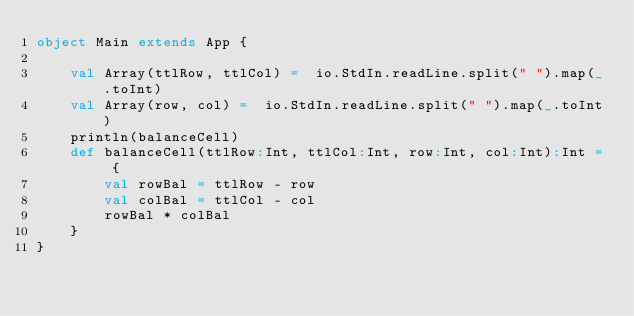<code> <loc_0><loc_0><loc_500><loc_500><_Scala_>object Main extends App {
     
    val Array(ttlRow, ttlCol) =  io.StdIn.readLine.split(" ").map(_.toInt)
    val Array(row, col) =  io.StdIn.readLine.split(" ").map(_.toInt)
    println(balanceCell)
    def balanceCell(ttlRow:Int, ttlCol:Int, row:Int, col:Int):Int = {
        val rowBal = ttlRow - row 
        val colBal = ttlCol - col 
        rowBal * colBal 
    }
}</code> 